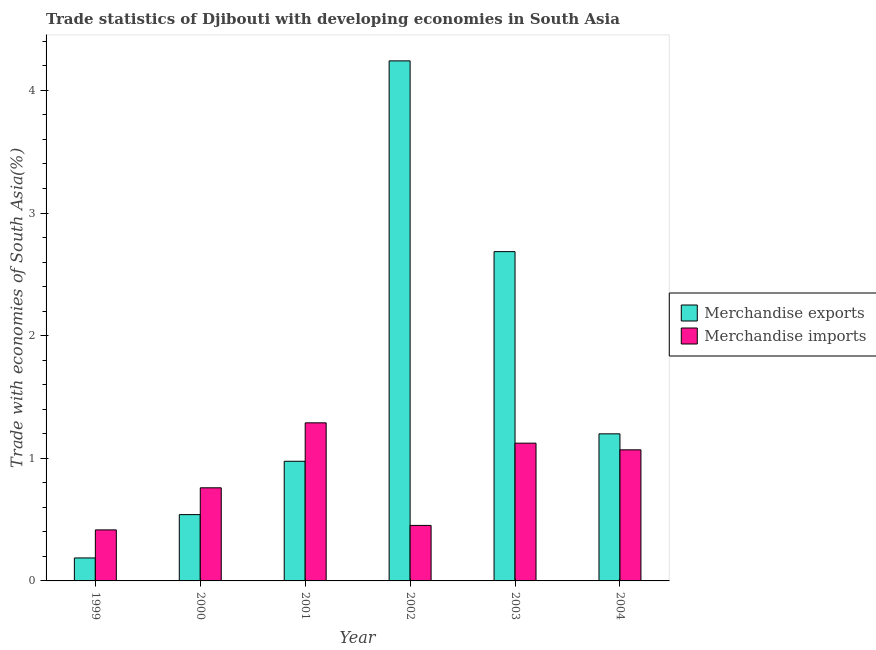How many different coloured bars are there?
Your response must be concise. 2. Are the number of bars per tick equal to the number of legend labels?
Offer a terse response. Yes. Are the number of bars on each tick of the X-axis equal?
Provide a succinct answer. Yes. How many bars are there on the 6th tick from the right?
Provide a succinct answer. 2. What is the merchandise exports in 2000?
Offer a very short reply. 0.54. Across all years, what is the maximum merchandise exports?
Your answer should be compact. 4.24. Across all years, what is the minimum merchandise imports?
Ensure brevity in your answer.  0.42. In which year was the merchandise imports minimum?
Your answer should be compact. 1999. What is the total merchandise exports in the graph?
Offer a terse response. 9.83. What is the difference between the merchandise imports in 2001 and that in 2002?
Offer a very short reply. 0.84. What is the difference between the merchandise exports in 2003 and the merchandise imports in 1999?
Ensure brevity in your answer.  2.5. What is the average merchandise imports per year?
Keep it short and to the point. 0.85. What is the ratio of the merchandise exports in 2002 to that in 2004?
Keep it short and to the point. 3.54. Is the merchandise exports in 2000 less than that in 2001?
Offer a very short reply. Yes. What is the difference between the highest and the second highest merchandise exports?
Offer a terse response. 1.56. What is the difference between the highest and the lowest merchandise exports?
Provide a succinct answer. 4.05. In how many years, is the merchandise exports greater than the average merchandise exports taken over all years?
Give a very brief answer. 2. Is the sum of the merchandise imports in 2000 and 2004 greater than the maximum merchandise exports across all years?
Provide a succinct answer. Yes. What does the 1st bar from the left in 2001 represents?
Your answer should be very brief. Merchandise exports. Are all the bars in the graph horizontal?
Keep it short and to the point. No. How many years are there in the graph?
Give a very brief answer. 6. What is the difference between two consecutive major ticks on the Y-axis?
Ensure brevity in your answer.  1. How many legend labels are there?
Give a very brief answer. 2. How are the legend labels stacked?
Provide a succinct answer. Vertical. What is the title of the graph?
Your answer should be compact. Trade statistics of Djibouti with developing economies in South Asia. Does "Males" appear as one of the legend labels in the graph?
Offer a terse response. No. What is the label or title of the X-axis?
Offer a very short reply. Year. What is the label or title of the Y-axis?
Provide a succinct answer. Trade with economies of South Asia(%). What is the Trade with economies of South Asia(%) in Merchandise exports in 1999?
Offer a terse response. 0.19. What is the Trade with economies of South Asia(%) of Merchandise imports in 1999?
Make the answer very short. 0.42. What is the Trade with economies of South Asia(%) in Merchandise exports in 2000?
Provide a short and direct response. 0.54. What is the Trade with economies of South Asia(%) of Merchandise imports in 2000?
Keep it short and to the point. 0.76. What is the Trade with economies of South Asia(%) in Merchandise exports in 2001?
Offer a terse response. 0.98. What is the Trade with economies of South Asia(%) of Merchandise imports in 2001?
Your response must be concise. 1.29. What is the Trade with economies of South Asia(%) in Merchandise exports in 2002?
Offer a very short reply. 4.24. What is the Trade with economies of South Asia(%) in Merchandise imports in 2002?
Provide a succinct answer. 0.45. What is the Trade with economies of South Asia(%) in Merchandise exports in 2003?
Provide a short and direct response. 2.68. What is the Trade with economies of South Asia(%) in Merchandise imports in 2003?
Provide a succinct answer. 1.12. What is the Trade with economies of South Asia(%) of Merchandise exports in 2004?
Your answer should be very brief. 1.2. What is the Trade with economies of South Asia(%) of Merchandise imports in 2004?
Your response must be concise. 1.07. Across all years, what is the maximum Trade with economies of South Asia(%) of Merchandise exports?
Give a very brief answer. 4.24. Across all years, what is the maximum Trade with economies of South Asia(%) in Merchandise imports?
Offer a terse response. 1.29. Across all years, what is the minimum Trade with economies of South Asia(%) of Merchandise exports?
Your response must be concise. 0.19. Across all years, what is the minimum Trade with economies of South Asia(%) of Merchandise imports?
Give a very brief answer. 0.42. What is the total Trade with economies of South Asia(%) in Merchandise exports in the graph?
Ensure brevity in your answer.  9.83. What is the total Trade with economies of South Asia(%) in Merchandise imports in the graph?
Keep it short and to the point. 5.11. What is the difference between the Trade with economies of South Asia(%) in Merchandise exports in 1999 and that in 2000?
Your response must be concise. -0.35. What is the difference between the Trade with economies of South Asia(%) of Merchandise imports in 1999 and that in 2000?
Keep it short and to the point. -0.34. What is the difference between the Trade with economies of South Asia(%) of Merchandise exports in 1999 and that in 2001?
Make the answer very short. -0.79. What is the difference between the Trade with economies of South Asia(%) in Merchandise imports in 1999 and that in 2001?
Ensure brevity in your answer.  -0.87. What is the difference between the Trade with economies of South Asia(%) in Merchandise exports in 1999 and that in 2002?
Offer a terse response. -4.05. What is the difference between the Trade with economies of South Asia(%) in Merchandise imports in 1999 and that in 2002?
Your answer should be compact. -0.04. What is the difference between the Trade with economies of South Asia(%) of Merchandise exports in 1999 and that in 2003?
Offer a very short reply. -2.5. What is the difference between the Trade with economies of South Asia(%) in Merchandise imports in 1999 and that in 2003?
Offer a very short reply. -0.71. What is the difference between the Trade with economies of South Asia(%) in Merchandise exports in 1999 and that in 2004?
Ensure brevity in your answer.  -1.01. What is the difference between the Trade with economies of South Asia(%) of Merchandise imports in 1999 and that in 2004?
Offer a terse response. -0.65. What is the difference between the Trade with economies of South Asia(%) in Merchandise exports in 2000 and that in 2001?
Give a very brief answer. -0.43. What is the difference between the Trade with economies of South Asia(%) of Merchandise imports in 2000 and that in 2001?
Give a very brief answer. -0.53. What is the difference between the Trade with economies of South Asia(%) of Merchandise exports in 2000 and that in 2002?
Your answer should be very brief. -3.7. What is the difference between the Trade with economies of South Asia(%) in Merchandise imports in 2000 and that in 2002?
Your answer should be very brief. 0.31. What is the difference between the Trade with economies of South Asia(%) of Merchandise exports in 2000 and that in 2003?
Your response must be concise. -2.14. What is the difference between the Trade with economies of South Asia(%) of Merchandise imports in 2000 and that in 2003?
Give a very brief answer. -0.36. What is the difference between the Trade with economies of South Asia(%) in Merchandise exports in 2000 and that in 2004?
Your response must be concise. -0.66. What is the difference between the Trade with economies of South Asia(%) of Merchandise imports in 2000 and that in 2004?
Your response must be concise. -0.31. What is the difference between the Trade with economies of South Asia(%) of Merchandise exports in 2001 and that in 2002?
Ensure brevity in your answer.  -3.26. What is the difference between the Trade with economies of South Asia(%) of Merchandise imports in 2001 and that in 2002?
Offer a terse response. 0.84. What is the difference between the Trade with economies of South Asia(%) in Merchandise exports in 2001 and that in 2003?
Give a very brief answer. -1.71. What is the difference between the Trade with economies of South Asia(%) in Merchandise imports in 2001 and that in 2003?
Give a very brief answer. 0.17. What is the difference between the Trade with economies of South Asia(%) of Merchandise exports in 2001 and that in 2004?
Your answer should be very brief. -0.22. What is the difference between the Trade with economies of South Asia(%) in Merchandise imports in 2001 and that in 2004?
Give a very brief answer. 0.22. What is the difference between the Trade with economies of South Asia(%) in Merchandise exports in 2002 and that in 2003?
Ensure brevity in your answer.  1.56. What is the difference between the Trade with economies of South Asia(%) in Merchandise imports in 2002 and that in 2003?
Your answer should be very brief. -0.67. What is the difference between the Trade with economies of South Asia(%) of Merchandise exports in 2002 and that in 2004?
Provide a succinct answer. 3.04. What is the difference between the Trade with economies of South Asia(%) of Merchandise imports in 2002 and that in 2004?
Your answer should be very brief. -0.62. What is the difference between the Trade with economies of South Asia(%) in Merchandise exports in 2003 and that in 2004?
Your answer should be compact. 1.49. What is the difference between the Trade with economies of South Asia(%) in Merchandise imports in 2003 and that in 2004?
Provide a short and direct response. 0.05. What is the difference between the Trade with economies of South Asia(%) of Merchandise exports in 1999 and the Trade with economies of South Asia(%) of Merchandise imports in 2000?
Your response must be concise. -0.57. What is the difference between the Trade with economies of South Asia(%) of Merchandise exports in 1999 and the Trade with economies of South Asia(%) of Merchandise imports in 2001?
Your answer should be compact. -1.1. What is the difference between the Trade with economies of South Asia(%) in Merchandise exports in 1999 and the Trade with economies of South Asia(%) in Merchandise imports in 2002?
Keep it short and to the point. -0.27. What is the difference between the Trade with economies of South Asia(%) in Merchandise exports in 1999 and the Trade with economies of South Asia(%) in Merchandise imports in 2003?
Keep it short and to the point. -0.94. What is the difference between the Trade with economies of South Asia(%) of Merchandise exports in 1999 and the Trade with economies of South Asia(%) of Merchandise imports in 2004?
Your answer should be very brief. -0.88. What is the difference between the Trade with economies of South Asia(%) in Merchandise exports in 2000 and the Trade with economies of South Asia(%) in Merchandise imports in 2001?
Make the answer very short. -0.75. What is the difference between the Trade with economies of South Asia(%) of Merchandise exports in 2000 and the Trade with economies of South Asia(%) of Merchandise imports in 2002?
Offer a terse response. 0.09. What is the difference between the Trade with economies of South Asia(%) of Merchandise exports in 2000 and the Trade with economies of South Asia(%) of Merchandise imports in 2003?
Offer a terse response. -0.58. What is the difference between the Trade with economies of South Asia(%) of Merchandise exports in 2000 and the Trade with economies of South Asia(%) of Merchandise imports in 2004?
Provide a short and direct response. -0.53. What is the difference between the Trade with economies of South Asia(%) in Merchandise exports in 2001 and the Trade with economies of South Asia(%) in Merchandise imports in 2002?
Keep it short and to the point. 0.52. What is the difference between the Trade with economies of South Asia(%) of Merchandise exports in 2001 and the Trade with economies of South Asia(%) of Merchandise imports in 2003?
Offer a very short reply. -0.15. What is the difference between the Trade with economies of South Asia(%) in Merchandise exports in 2001 and the Trade with economies of South Asia(%) in Merchandise imports in 2004?
Give a very brief answer. -0.09. What is the difference between the Trade with economies of South Asia(%) in Merchandise exports in 2002 and the Trade with economies of South Asia(%) in Merchandise imports in 2003?
Provide a succinct answer. 3.12. What is the difference between the Trade with economies of South Asia(%) of Merchandise exports in 2002 and the Trade with economies of South Asia(%) of Merchandise imports in 2004?
Ensure brevity in your answer.  3.17. What is the difference between the Trade with economies of South Asia(%) in Merchandise exports in 2003 and the Trade with economies of South Asia(%) in Merchandise imports in 2004?
Offer a very short reply. 1.62. What is the average Trade with economies of South Asia(%) of Merchandise exports per year?
Give a very brief answer. 1.64. What is the average Trade with economies of South Asia(%) in Merchandise imports per year?
Offer a very short reply. 0.85. In the year 1999, what is the difference between the Trade with economies of South Asia(%) in Merchandise exports and Trade with economies of South Asia(%) in Merchandise imports?
Offer a terse response. -0.23. In the year 2000, what is the difference between the Trade with economies of South Asia(%) in Merchandise exports and Trade with economies of South Asia(%) in Merchandise imports?
Make the answer very short. -0.22. In the year 2001, what is the difference between the Trade with economies of South Asia(%) of Merchandise exports and Trade with economies of South Asia(%) of Merchandise imports?
Ensure brevity in your answer.  -0.31. In the year 2002, what is the difference between the Trade with economies of South Asia(%) in Merchandise exports and Trade with economies of South Asia(%) in Merchandise imports?
Offer a terse response. 3.79. In the year 2003, what is the difference between the Trade with economies of South Asia(%) in Merchandise exports and Trade with economies of South Asia(%) in Merchandise imports?
Your answer should be compact. 1.56. In the year 2004, what is the difference between the Trade with economies of South Asia(%) in Merchandise exports and Trade with economies of South Asia(%) in Merchandise imports?
Your answer should be compact. 0.13. What is the ratio of the Trade with economies of South Asia(%) of Merchandise exports in 1999 to that in 2000?
Your response must be concise. 0.35. What is the ratio of the Trade with economies of South Asia(%) of Merchandise imports in 1999 to that in 2000?
Give a very brief answer. 0.55. What is the ratio of the Trade with economies of South Asia(%) in Merchandise exports in 1999 to that in 2001?
Provide a short and direct response. 0.19. What is the ratio of the Trade with economies of South Asia(%) of Merchandise imports in 1999 to that in 2001?
Offer a terse response. 0.32. What is the ratio of the Trade with economies of South Asia(%) in Merchandise exports in 1999 to that in 2002?
Make the answer very short. 0.04. What is the ratio of the Trade with economies of South Asia(%) of Merchandise imports in 1999 to that in 2002?
Your answer should be very brief. 0.92. What is the ratio of the Trade with economies of South Asia(%) of Merchandise exports in 1999 to that in 2003?
Keep it short and to the point. 0.07. What is the ratio of the Trade with economies of South Asia(%) in Merchandise imports in 1999 to that in 2003?
Provide a short and direct response. 0.37. What is the ratio of the Trade with economies of South Asia(%) in Merchandise exports in 1999 to that in 2004?
Give a very brief answer. 0.16. What is the ratio of the Trade with economies of South Asia(%) in Merchandise imports in 1999 to that in 2004?
Offer a terse response. 0.39. What is the ratio of the Trade with economies of South Asia(%) in Merchandise exports in 2000 to that in 2001?
Ensure brevity in your answer.  0.55. What is the ratio of the Trade with economies of South Asia(%) of Merchandise imports in 2000 to that in 2001?
Offer a terse response. 0.59. What is the ratio of the Trade with economies of South Asia(%) of Merchandise exports in 2000 to that in 2002?
Offer a very short reply. 0.13. What is the ratio of the Trade with economies of South Asia(%) of Merchandise imports in 2000 to that in 2002?
Provide a short and direct response. 1.68. What is the ratio of the Trade with economies of South Asia(%) of Merchandise exports in 2000 to that in 2003?
Your response must be concise. 0.2. What is the ratio of the Trade with economies of South Asia(%) of Merchandise imports in 2000 to that in 2003?
Your response must be concise. 0.68. What is the ratio of the Trade with economies of South Asia(%) in Merchandise exports in 2000 to that in 2004?
Your answer should be compact. 0.45. What is the ratio of the Trade with economies of South Asia(%) in Merchandise imports in 2000 to that in 2004?
Ensure brevity in your answer.  0.71. What is the ratio of the Trade with economies of South Asia(%) in Merchandise exports in 2001 to that in 2002?
Offer a terse response. 0.23. What is the ratio of the Trade with economies of South Asia(%) of Merchandise imports in 2001 to that in 2002?
Your response must be concise. 2.85. What is the ratio of the Trade with economies of South Asia(%) of Merchandise exports in 2001 to that in 2003?
Make the answer very short. 0.36. What is the ratio of the Trade with economies of South Asia(%) of Merchandise imports in 2001 to that in 2003?
Give a very brief answer. 1.15. What is the ratio of the Trade with economies of South Asia(%) in Merchandise exports in 2001 to that in 2004?
Ensure brevity in your answer.  0.81. What is the ratio of the Trade with economies of South Asia(%) of Merchandise imports in 2001 to that in 2004?
Offer a terse response. 1.21. What is the ratio of the Trade with economies of South Asia(%) of Merchandise exports in 2002 to that in 2003?
Your answer should be very brief. 1.58. What is the ratio of the Trade with economies of South Asia(%) of Merchandise imports in 2002 to that in 2003?
Ensure brevity in your answer.  0.4. What is the ratio of the Trade with economies of South Asia(%) of Merchandise exports in 2002 to that in 2004?
Offer a very short reply. 3.54. What is the ratio of the Trade with economies of South Asia(%) of Merchandise imports in 2002 to that in 2004?
Ensure brevity in your answer.  0.42. What is the ratio of the Trade with economies of South Asia(%) in Merchandise exports in 2003 to that in 2004?
Keep it short and to the point. 2.24. What is the ratio of the Trade with economies of South Asia(%) in Merchandise imports in 2003 to that in 2004?
Provide a succinct answer. 1.05. What is the difference between the highest and the second highest Trade with economies of South Asia(%) of Merchandise exports?
Give a very brief answer. 1.56. What is the difference between the highest and the second highest Trade with economies of South Asia(%) of Merchandise imports?
Offer a terse response. 0.17. What is the difference between the highest and the lowest Trade with economies of South Asia(%) in Merchandise exports?
Provide a succinct answer. 4.05. What is the difference between the highest and the lowest Trade with economies of South Asia(%) of Merchandise imports?
Offer a terse response. 0.87. 